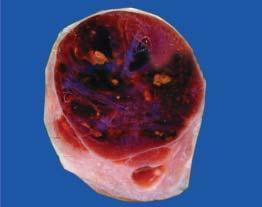s inset enlarged diffusely?
Answer the question using a single word or phrase. No 